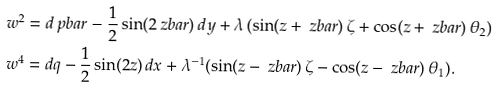Convert formula to latex. <formula><loc_0><loc_0><loc_500><loc_500>\ w ^ { 2 } & = d \ p b a r - \frac { 1 } { 2 } \sin ( 2 \ z b a r ) \, d y + \lambda \, ( \sin ( z + \ z b a r ) \, \zeta + \cos ( z + \ z b a r ) \, \theta _ { 2 } ) \\ \ w ^ { 4 } & = d q - \frac { 1 } { 2 } \sin ( 2 z ) \, d x + \lambda ^ { - 1 } ( \sin ( z - \ z b a r ) \, \zeta - \cos ( z - \ z b a r ) \, \theta _ { 1 } ) .</formula> 